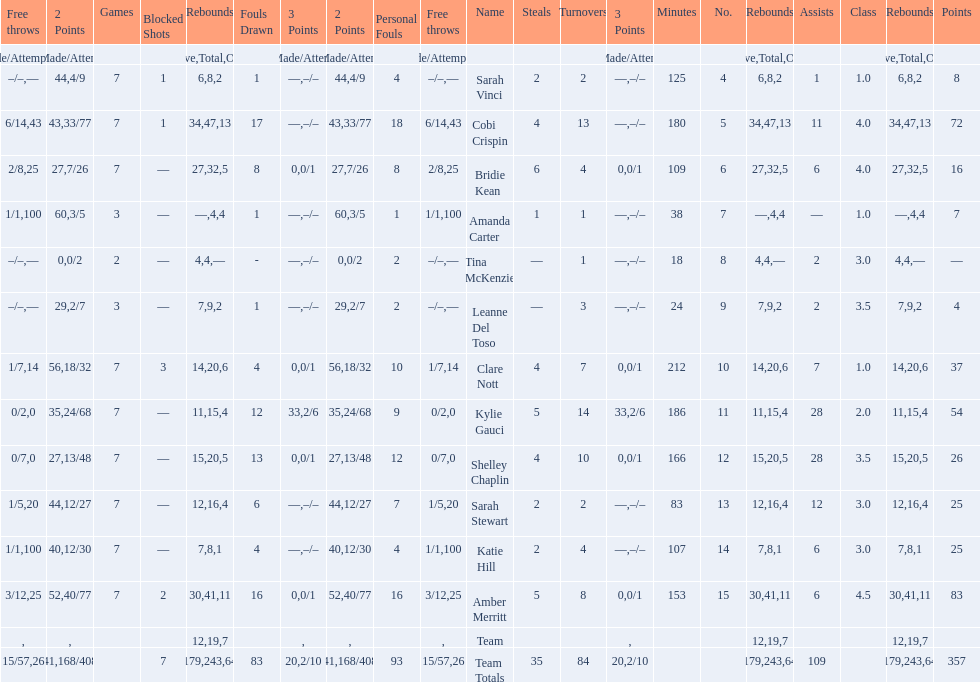Next to merritt, who was the top scorer? Cobi Crispin. 